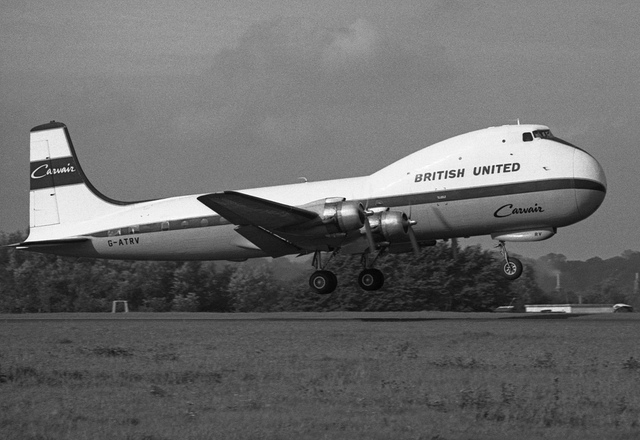<image>What is the paint color of the world British United? I'm not sure about the paint color of the word 'British United'. It can be seen black or white. What is the paint color of the world British United? I am not sure about the paint color of the world British United. It can be either black or white. 